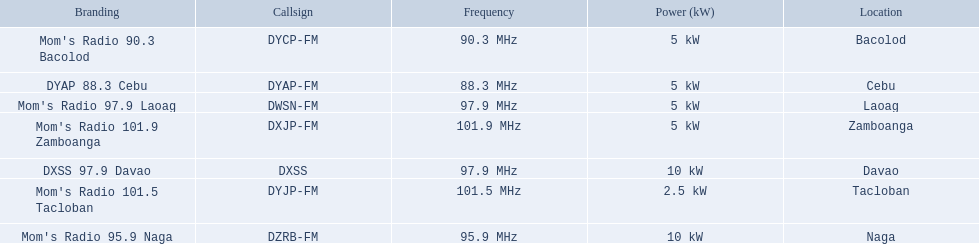What are all of the frequencies? 97.9 MHz, 95.9 MHz, 90.3 MHz, 88.3 MHz, 101.5 MHz, 101.9 MHz, 97.9 MHz. Which of these frequencies is the lowest? 88.3 MHz. Which branding does this frequency belong to? DYAP 88.3 Cebu. 